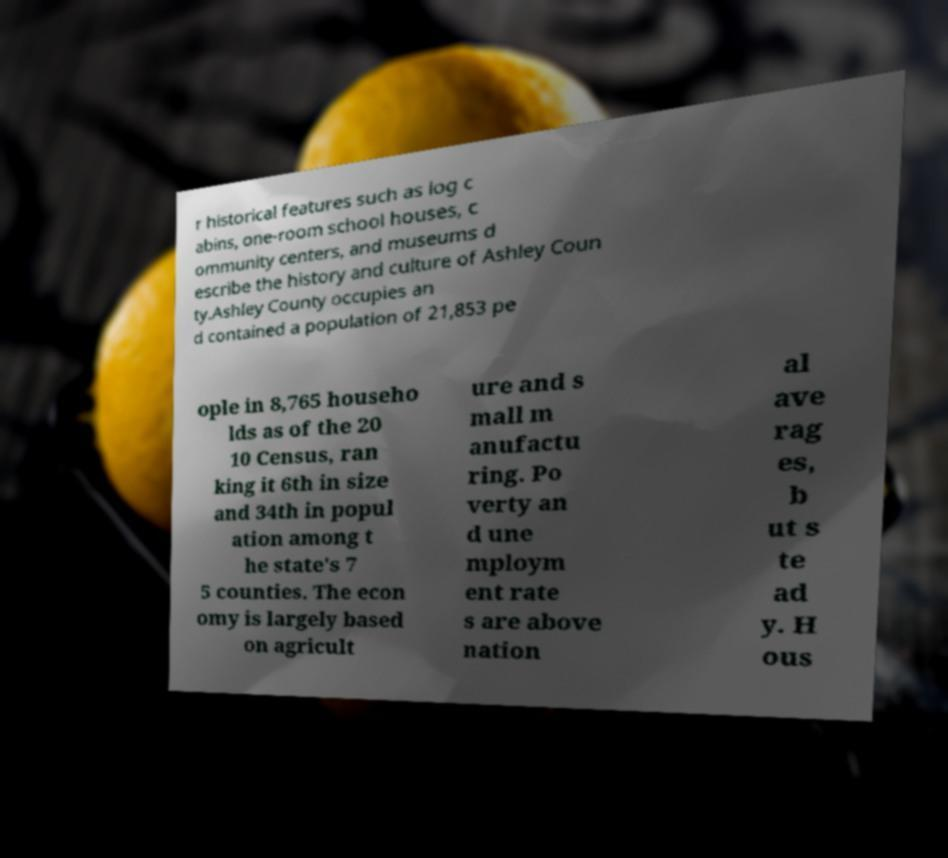For documentation purposes, I need the text within this image transcribed. Could you provide that? r historical features such as log c abins, one-room school houses, c ommunity centers, and museums d escribe the history and culture of Ashley Coun ty.Ashley County occupies an d contained a population of 21,853 pe ople in 8,765 househo lds as of the 20 10 Census, ran king it 6th in size and 34th in popul ation among t he state's 7 5 counties. The econ omy is largely based on agricult ure and s mall m anufactu ring. Po verty an d une mploym ent rate s are above nation al ave rag es, b ut s te ad y. H ous 